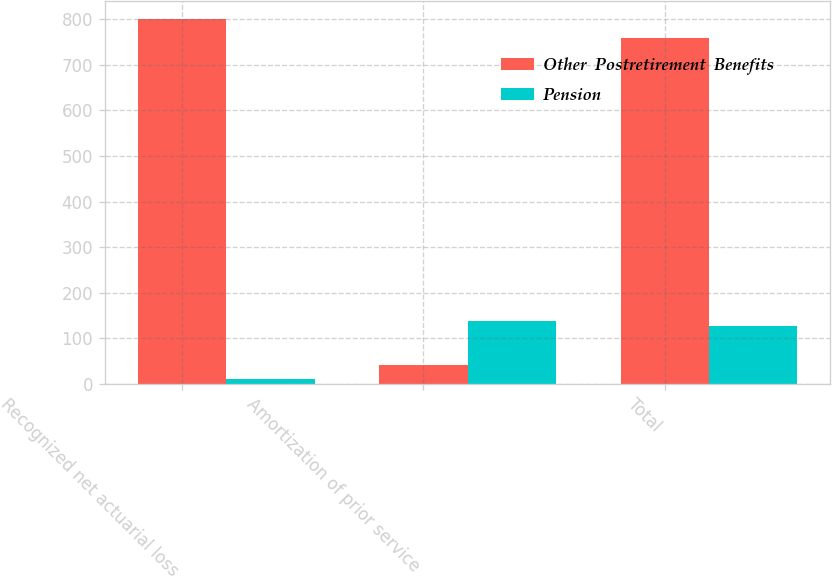Convert chart. <chart><loc_0><loc_0><loc_500><loc_500><stacked_bar_chart><ecel><fcel>Recognized net actuarial loss<fcel>Amortization of prior service<fcel>Total<nl><fcel>Other  Postretirement  Benefits<fcel>801<fcel>41<fcel>760<nl><fcel>Pension<fcel>10<fcel>137<fcel>127<nl></chart> 